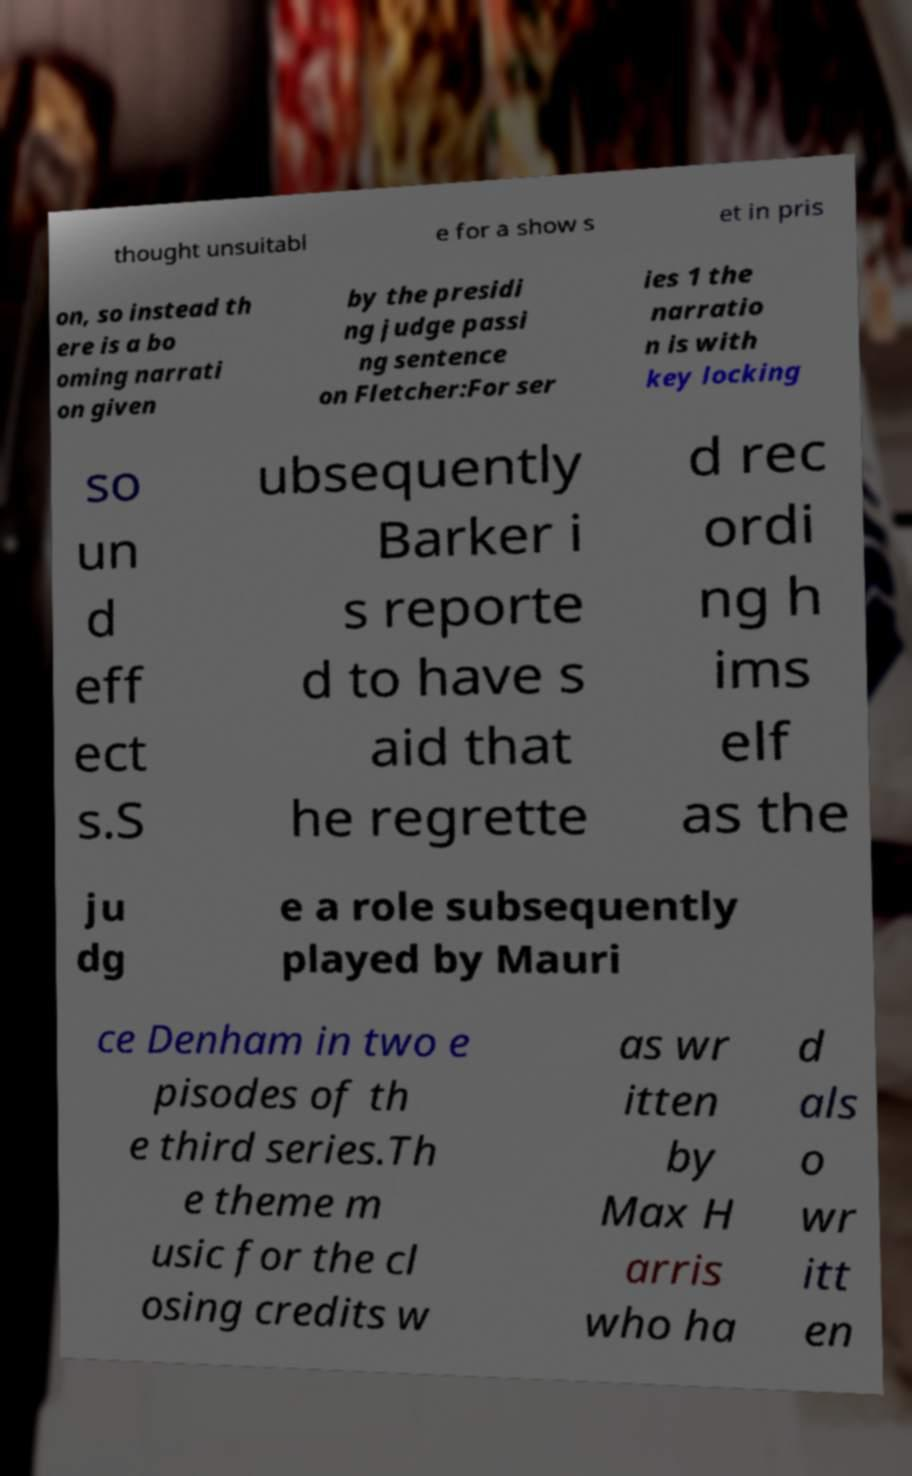Could you extract and type out the text from this image? thought unsuitabl e for a show s et in pris on, so instead th ere is a bo oming narrati on given by the presidi ng judge passi ng sentence on Fletcher:For ser ies 1 the narratio n is with key locking so un d eff ect s.S ubsequently Barker i s reporte d to have s aid that he regrette d rec ordi ng h ims elf as the ju dg e a role subsequently played by Mauri ce Denham in two e pisodes of th e third series.Th e theme m usic for the cl osing credits w as wr itten by Max H arris who ha d als o wr itt en 